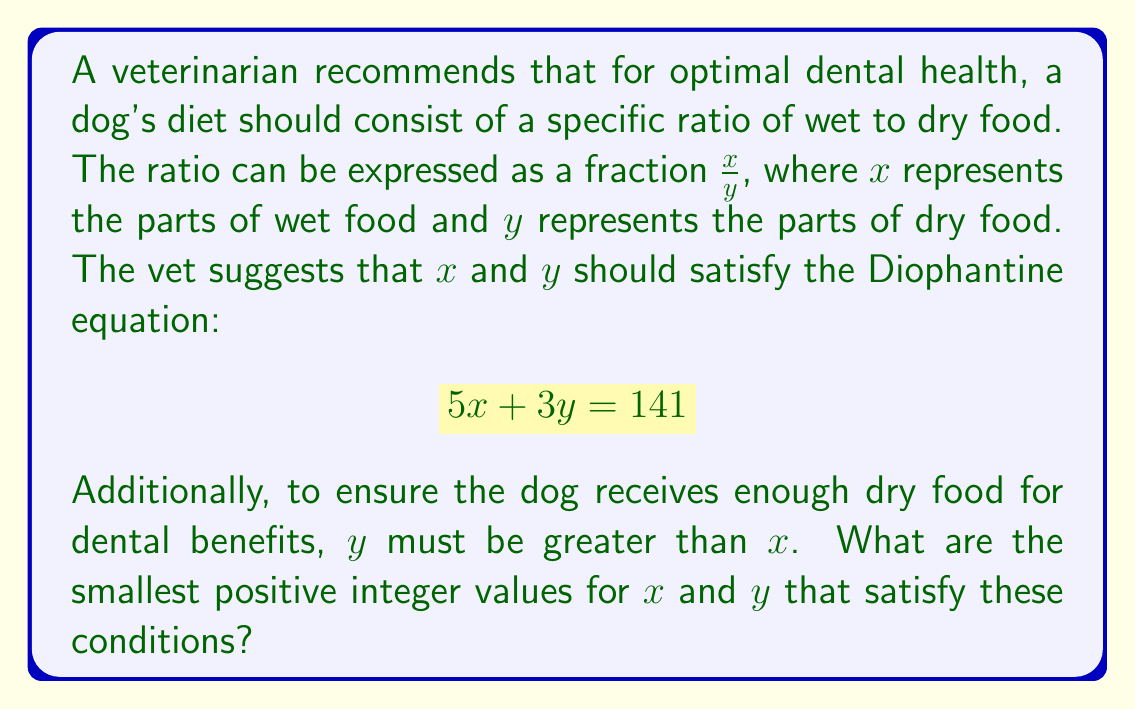What is the answer to this math problem? To solve this Diophantine equation while satisfying the given conditions, we can follow these steps:

1) We start with the equation $5x + 3y = 141$.

2) We know that $y > x$, so let's express $y$ in terms of $x$:
   $y = x + k$, where $k$ is a positive integer.

3) Substituting this into our original equation:
   $5x + 3(x + k) = 141$
   $5x + 3x + 3k = 141$
   $8x + 3k = 141$

4) Rearranging:
   $8x = 141 - 3k$

5) For $x$ to be an integer, $(141 - 3k)$ must be divisible by 8.

6) We can test values of $k$ starting from 1:
   For $k = 1$: $141 - 3(1) = 138$, not divisible by 8
   For $k = 2$: $141 - 3(2) = 135$, not divisible by 8
   For $k = 3$: $141 - 3(3) = 132$, not divisible by 8
   For $k = 4$: $141 - 3(4) = 129$, not divisible by 8
   For $k = 5$: $141 - 3(5) = 126$, not divisible by 8
   For $k = 6$: $141 - 3(6) = 123$, not divisible by 8
   For $k = 7$: $141 - 3(7) = 120$, which is divisible by 8

7) When $k = 7$, we have:
   $8x = 120$
   $x = 15$

8) We can find $y$ using $y = x + k$:
   $y = 15 + 7 = 22$

9) We can verify:
   $5(15) + 3(22) = 75 + 66 = 141$

10) We also confirm that $y > x$ (22 > 15).

Therefore, the smallest positive integer values for $x$ and $y$ that satisfy the conditions are $x = 15$ and $y = 22$.
Answer: $x = 15$, $y = 22$ 